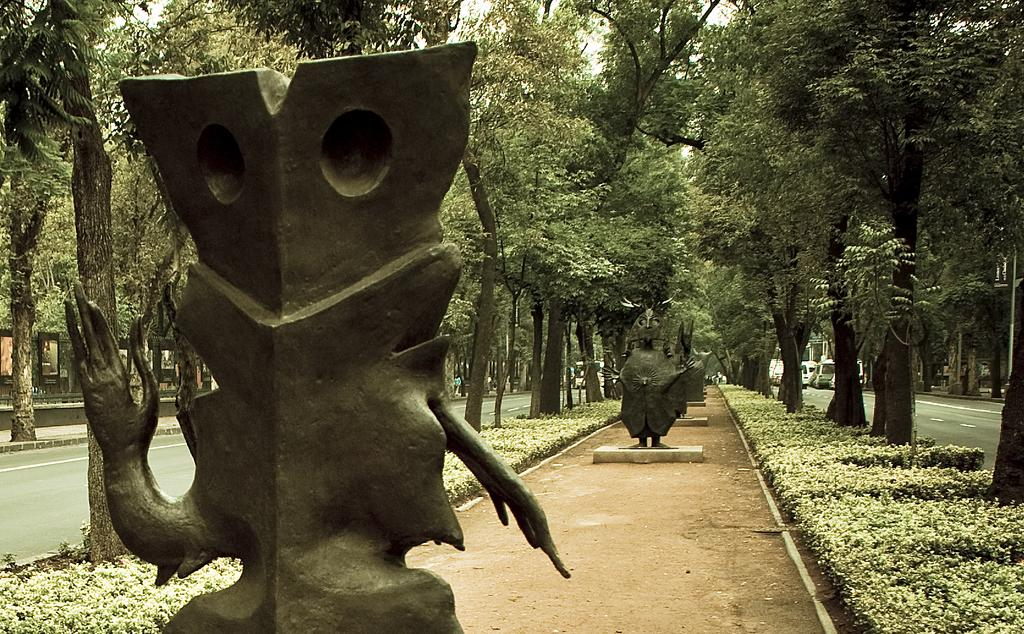What is the main subject in the foreground of the image? There is a sculpture in the foreground of the image. What can be seen in the background of the image? There are trees, plants, sculptures, vehicles, and the sky visible in the background of the image. How many types of objects can be seen in the background of the image? There are five types of objects visible in the background: trees, plants, sculptures, vehicles, and the sky. Can you see a tent in the image? There is no tent present in the image. How does the giraffe shake the tree in the image? There is no giraffe present in the image, so it cannot shake any trees. 